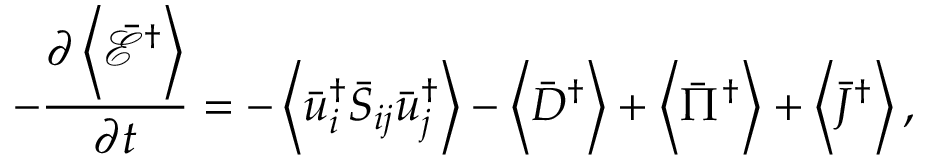Convert formula to latex. <formula><loc_0><loc_0><loc_500><loc_500>- \frac { { \partial \left \langle { { { \bar { \mathcal { E } } } ^ { \dag } } } \right \rangle } } { \partial t } = - \left \langle { \bar { u } _ { i } ^ { \dag } { { \bar { S } } _ { i j } } \bar { u } _ { j } ^ { \dag } } \right \rangle - \left \langle { { { \bar { D } } ^ { \dag } } } \right \rangle + \left \langle { { { \bar { \Pi } } ^ { \dag } } } \right \rangle + \left \langle { { { \bar { J } } ^ { \dag } } } \right \rangle ,</formula> 